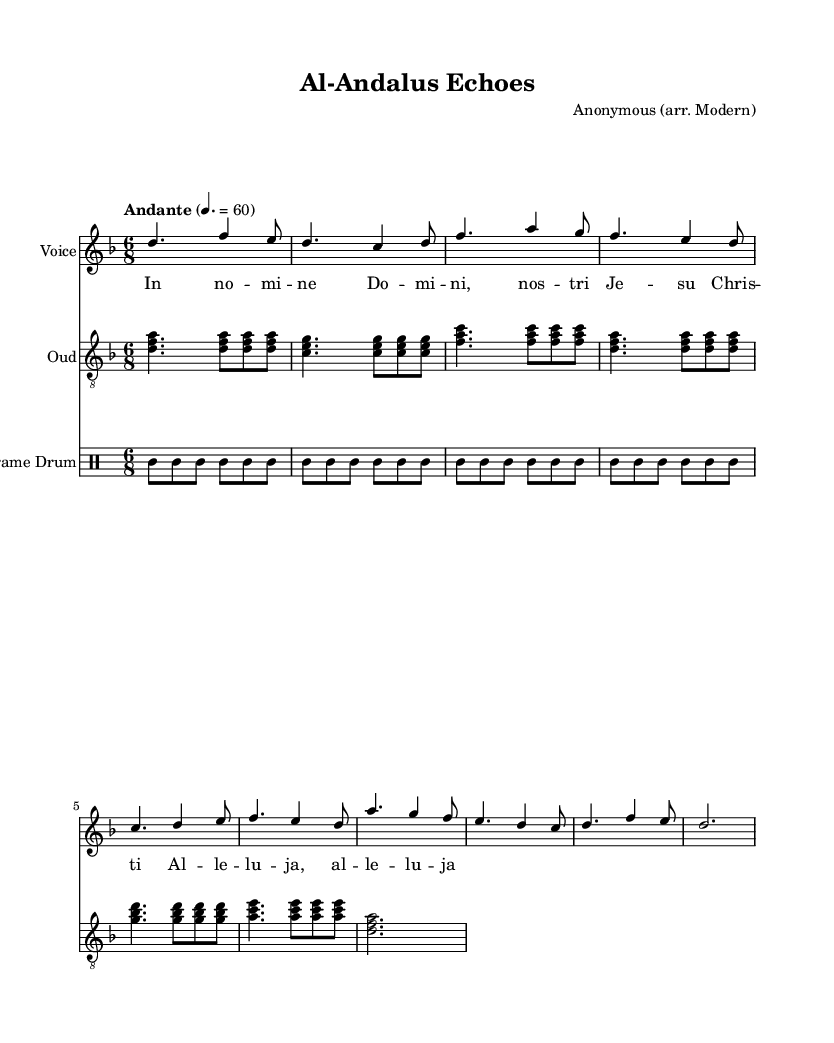What is the key signature of this music? The key signature shown in the music is D minor, indicated by one flat.
Answer: D minor What is the time signature of this music? The time signature is 6/8, which is a compound time signature indicating six eighth-note beats per measure.
Answer: 6/8 What is the tempo marking in this piece? The tempo marking is "Andante" with a metronome marking of 60 beats per minute, suggesting a moderately slow pace.
Answer: Andante How many measures are there in the refrain? The refrain consists of two measures, as shown in the score section format.
Answer: 2 What is the total number of voices indicated in this score? The score indicates two distinct voices—one for the vocal part and another for the oud, and a separate staff for drums.
Answer: 2 In what style is this piece primarily composed? The piece is composed in a modern interpretation of Mozarabic chants, which is reflected in its modal characteristics and rhythmic patterns.
Answer: Modern interpretation of Mozarabic chants What is the first note of the oud part? The first note of the oud part is D, as indicated by the chord played at the beginning of the oud staff.
Answer: D 